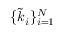Convert formula to latex. <formula><loc_0><loc_0><loc_500><loc_500>\{ \widetilde { k } _ { i } \} _ { i = 1 } ^ { N }</formula> 